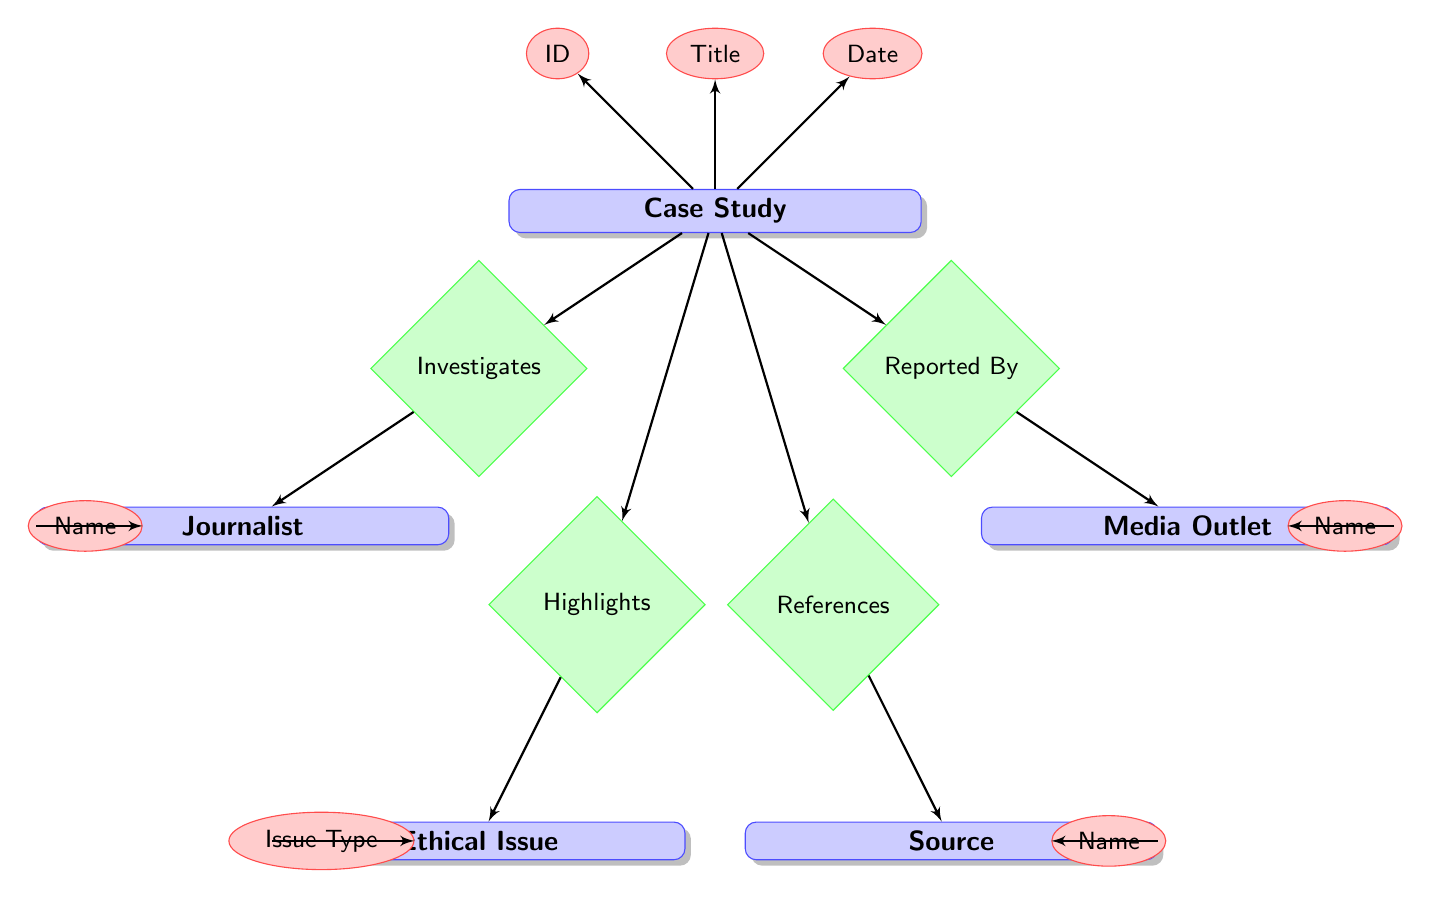What is the ID of the Case Study entity? The ID is an attribute under the Case Study entity, which is directly connected to it in the diagram.
Answer: ID How many entities are present in the diagram? By counting the distinct entities shown in the diagram, we find there are five different entities: Case Study, Journalist, Media Outlet, Ethical Issue, and Source.
Answer: 5 Who is the role played in the Source entity? The role is an attribute of the Source entity, which outlines the responsibility or function of the source in the context of a case study.
Answer: Role What relationship connects a Journalist to a Case Study? The connection is illustrated by the Investigates relationship, which shows the action taken by the journalist in association with the case study.
Answer: Investigates Which entity contains the attribute Name associated with the Media Outlet? The Media Outlet entity, which holds various attributes related to media organizations, includes the Name attribute.
Answer: Media Outlet What two entities are involved in the Highlights relationship? The relationship connects the Case Study entity and the Ethical Issue entity, indicating that the case study brings certain ethical issues to light.
Answer: Case Study and Ethical Issue In what relationship is the ReferenceDate attribute featured? The ReferenceDate is associated with the References relationship, indicating its connection to the Case Study and Source entities.
Answer: References How many relationships are there in the diagram? Counting the distinct relationships depicted, we find there are four: Investigates, Reported By, Highlights, and References, which establish the interactions among the entities.
Answer: 4 Which entity would you look at to find the Description of an Ethical Issue? The Description attribute is part of the Ethical Issue entity, which details what the ethical issue encompasses within a case study context.
Answer: Ethical Issue 